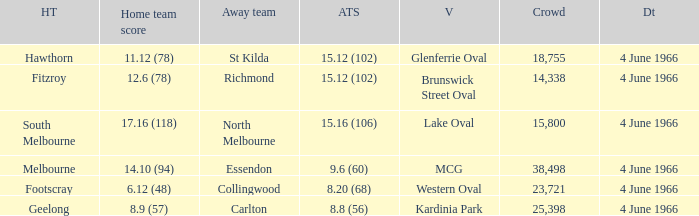What is the score of the away team that played home team Geelong? 8.8 (56). 